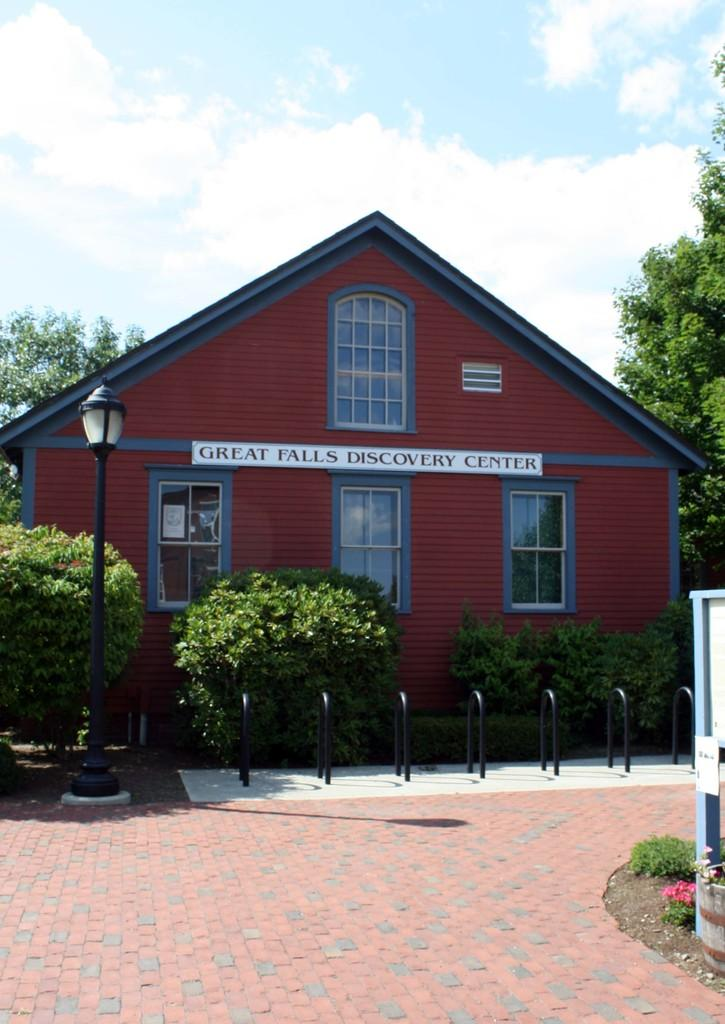What type of vegetation is present on the ground in the image? There is grass and flowers on the ground in the image. What type of artificial light source can be seen in the image? There is a street light in the image. What other types of vegetation are present in the image? There are plants in the image. What type of structure is visible in the image? There is a house in the image. What are the rods used for in the image? The purpose of the rods in the image is not specified, but they are present. What else can be seen in the image besides the mentioned objects? There are other objects in the image. What is the weather like in the image? The sky is cloudy in the image. What type of powder is being used to create the clouds in the image? There is no indication that the clouds in the image were created using powder; they are a natural weather phenomenon. What advice would the grandfather give to the people in the image? There is no grandfather present in the image, so it is not possible to determine what advice he might give. 